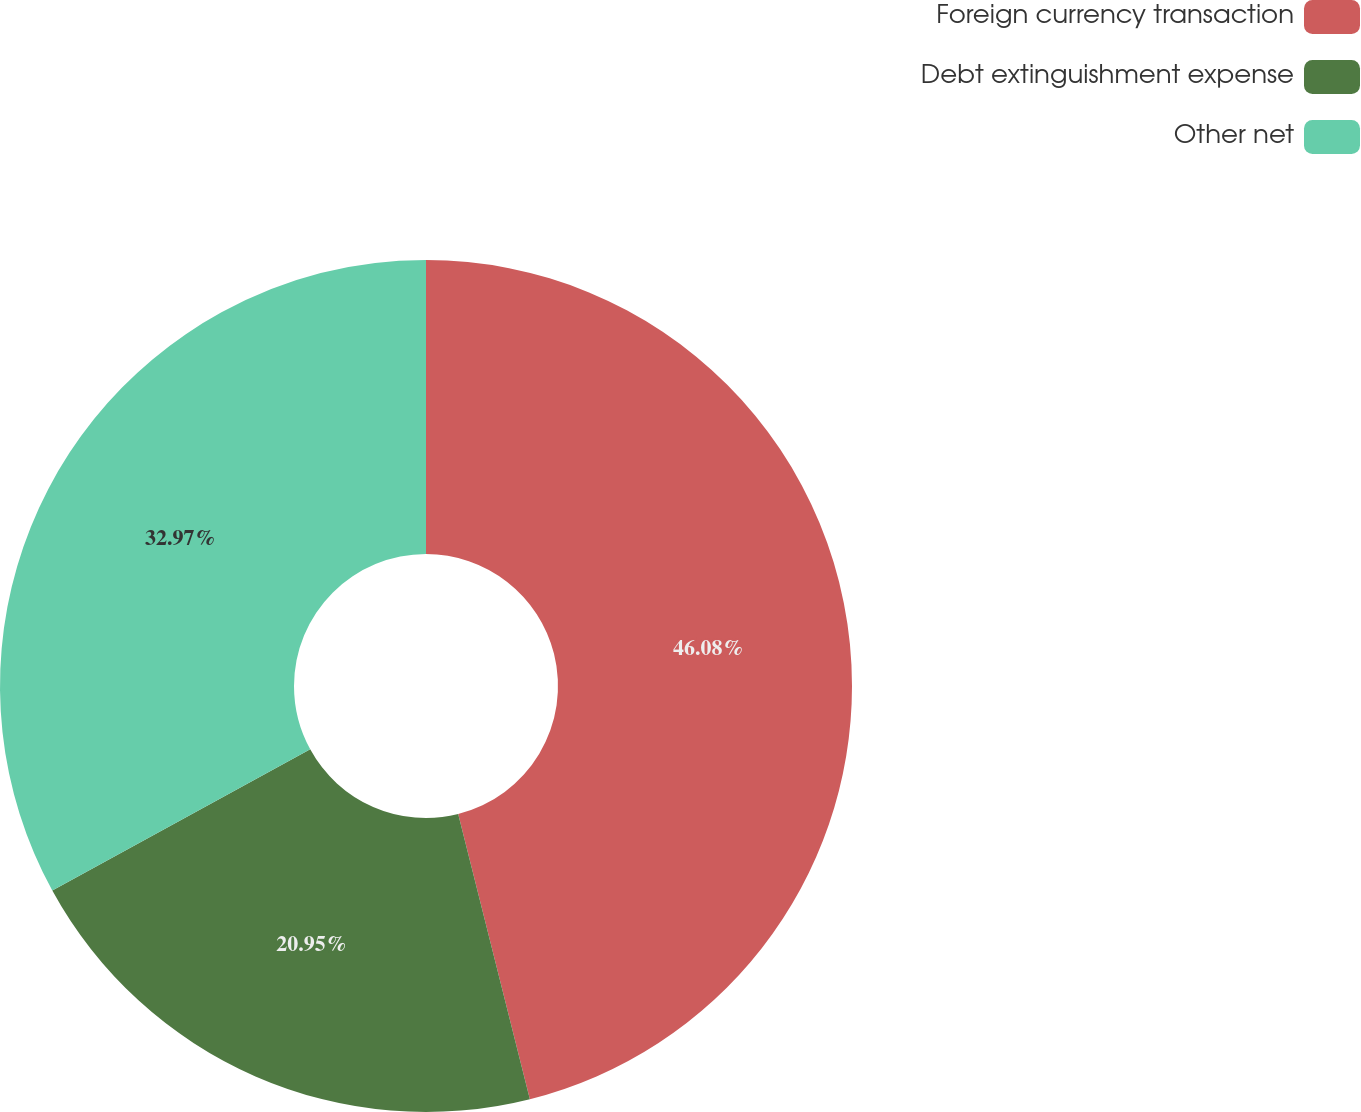<chart> <loc_0><loc_0><loc_500><loc_500><pie_chart><fcel>Foreign currency transaction<fcel>Debt extinguishment expense<fcel>Other net<nl><fcel>46.08%<fcel>20.95%<fcel>32.97%<nl></chart> 